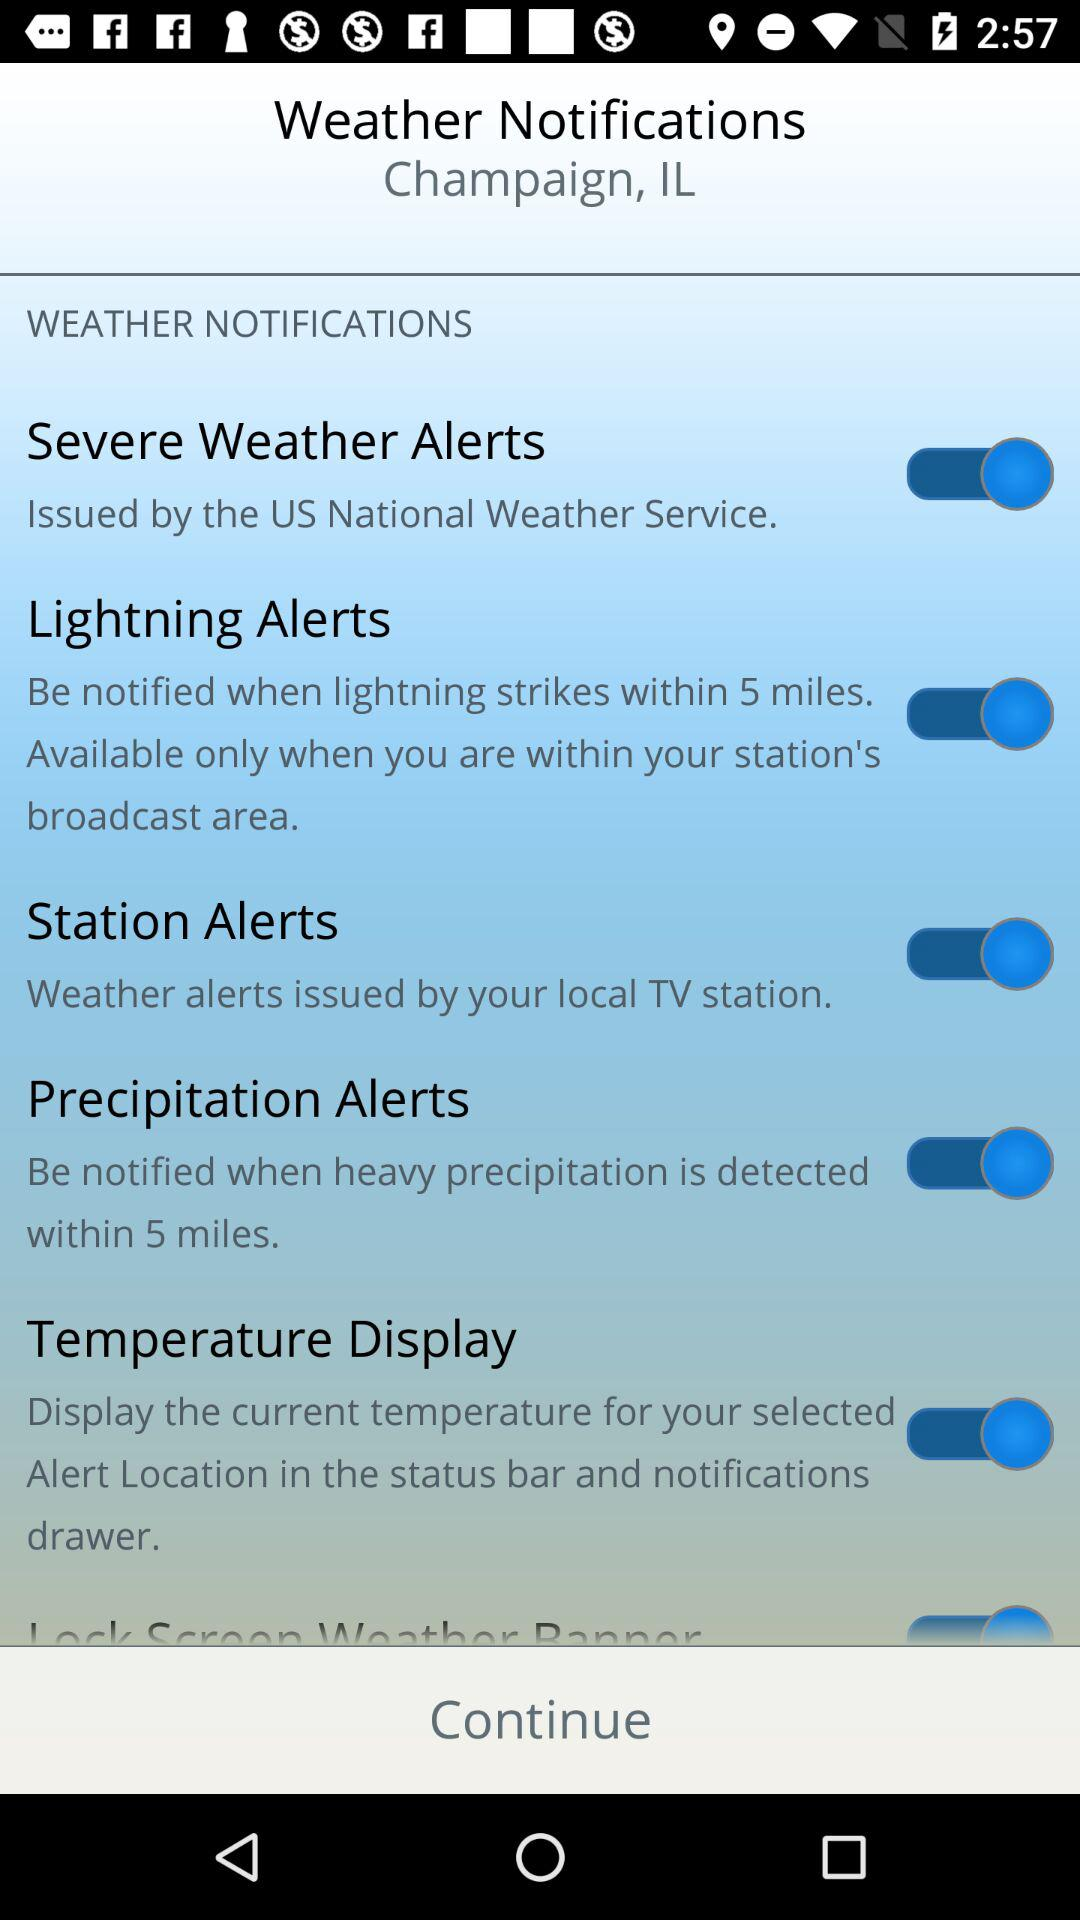What is the mentioned location? The mentioned location is Champaign, IL. 